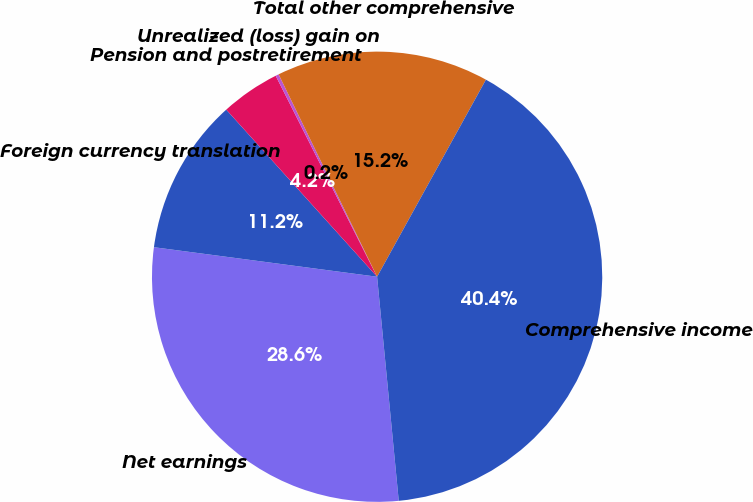<chart> <loc_0><loc_0><loc_500><loc_500><pie_chart><fcel>Net earnings<fcel>Foreign currency translation<fcel>Pension and postretirement<fcel>Unrealized (loss) gain on<fcel>Total other comprehensive<fcel>Comprehensive income<nl><fcel>28.63%<fcel>11.22%<fcel>4.25%<fcel>0.23%<fcel>15.24%<fcel>40.44%<nl></chart> 